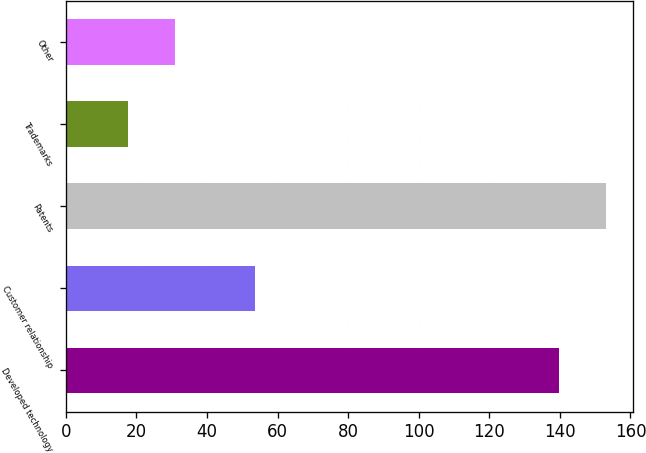Convert chart to OTSL. <chart><loc_0><loc_0><loc_500><loc_500><bar_chart><fcel>Developed technology<fcel>Customer relationship<fcel>Patents<fcel>Trademarks<fcel>Other<nl><fcel>139.7<fcel>53.7<fcel>153.13<fcel>17.5<fcel>30.93<nl></chart> 